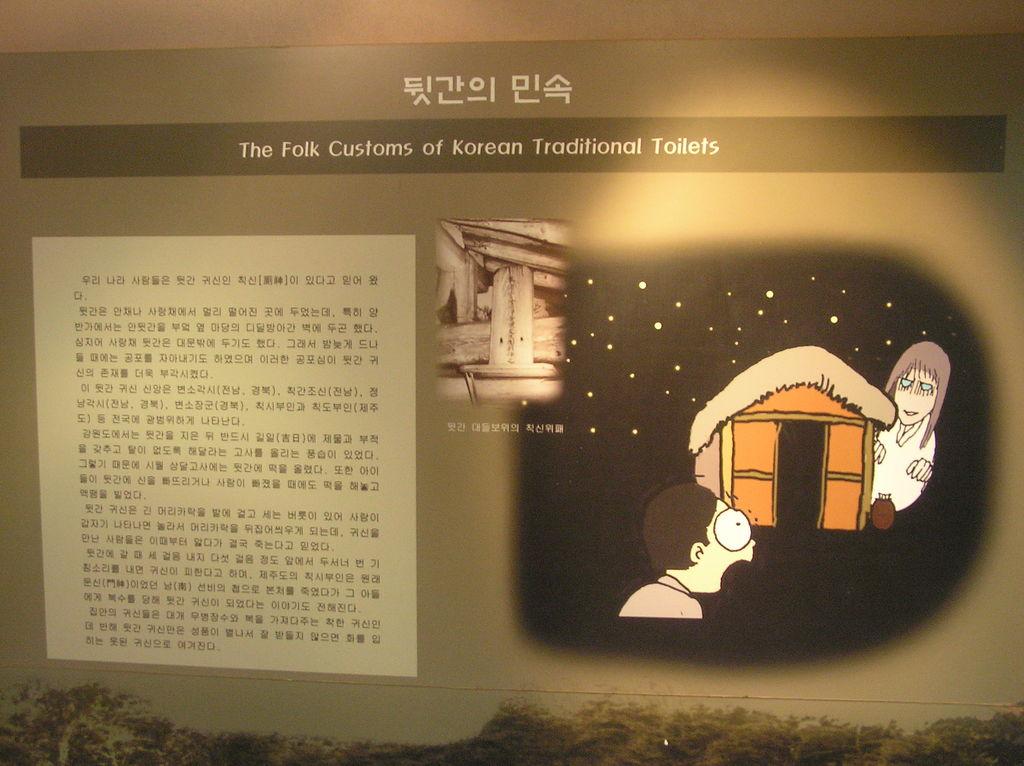About what country is this information?
Make the answer very short. Korea. The subject is about what?
Make the answer very short. Folk customs of korean traditional toilets. 